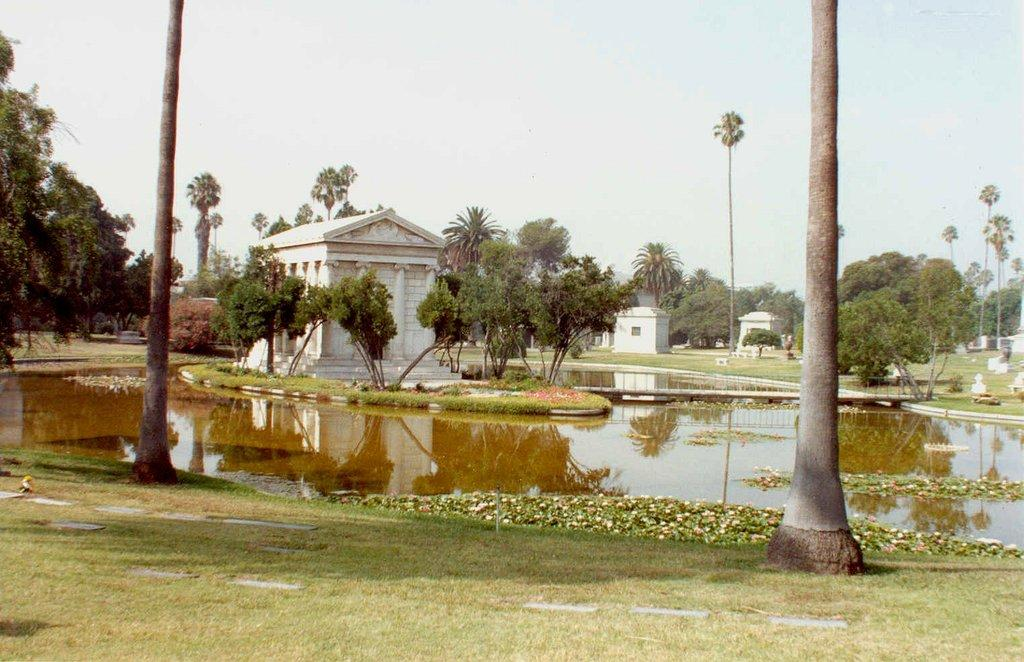What is one of the natural elements present in the image? There is water in the image. What type of vegetation can be seen in the image? There are trees and plants in the image. What type of structures are visible in the image? There are houses in the image. What type of ground cover is present in the image? There is grass in the image. What can be seen in the background of the image? The sky is visible in the background of the image. What type of chalk is being used to draw on the houses in the image? There is no chalk present in the image, nor is anyone drawing on the houses. 